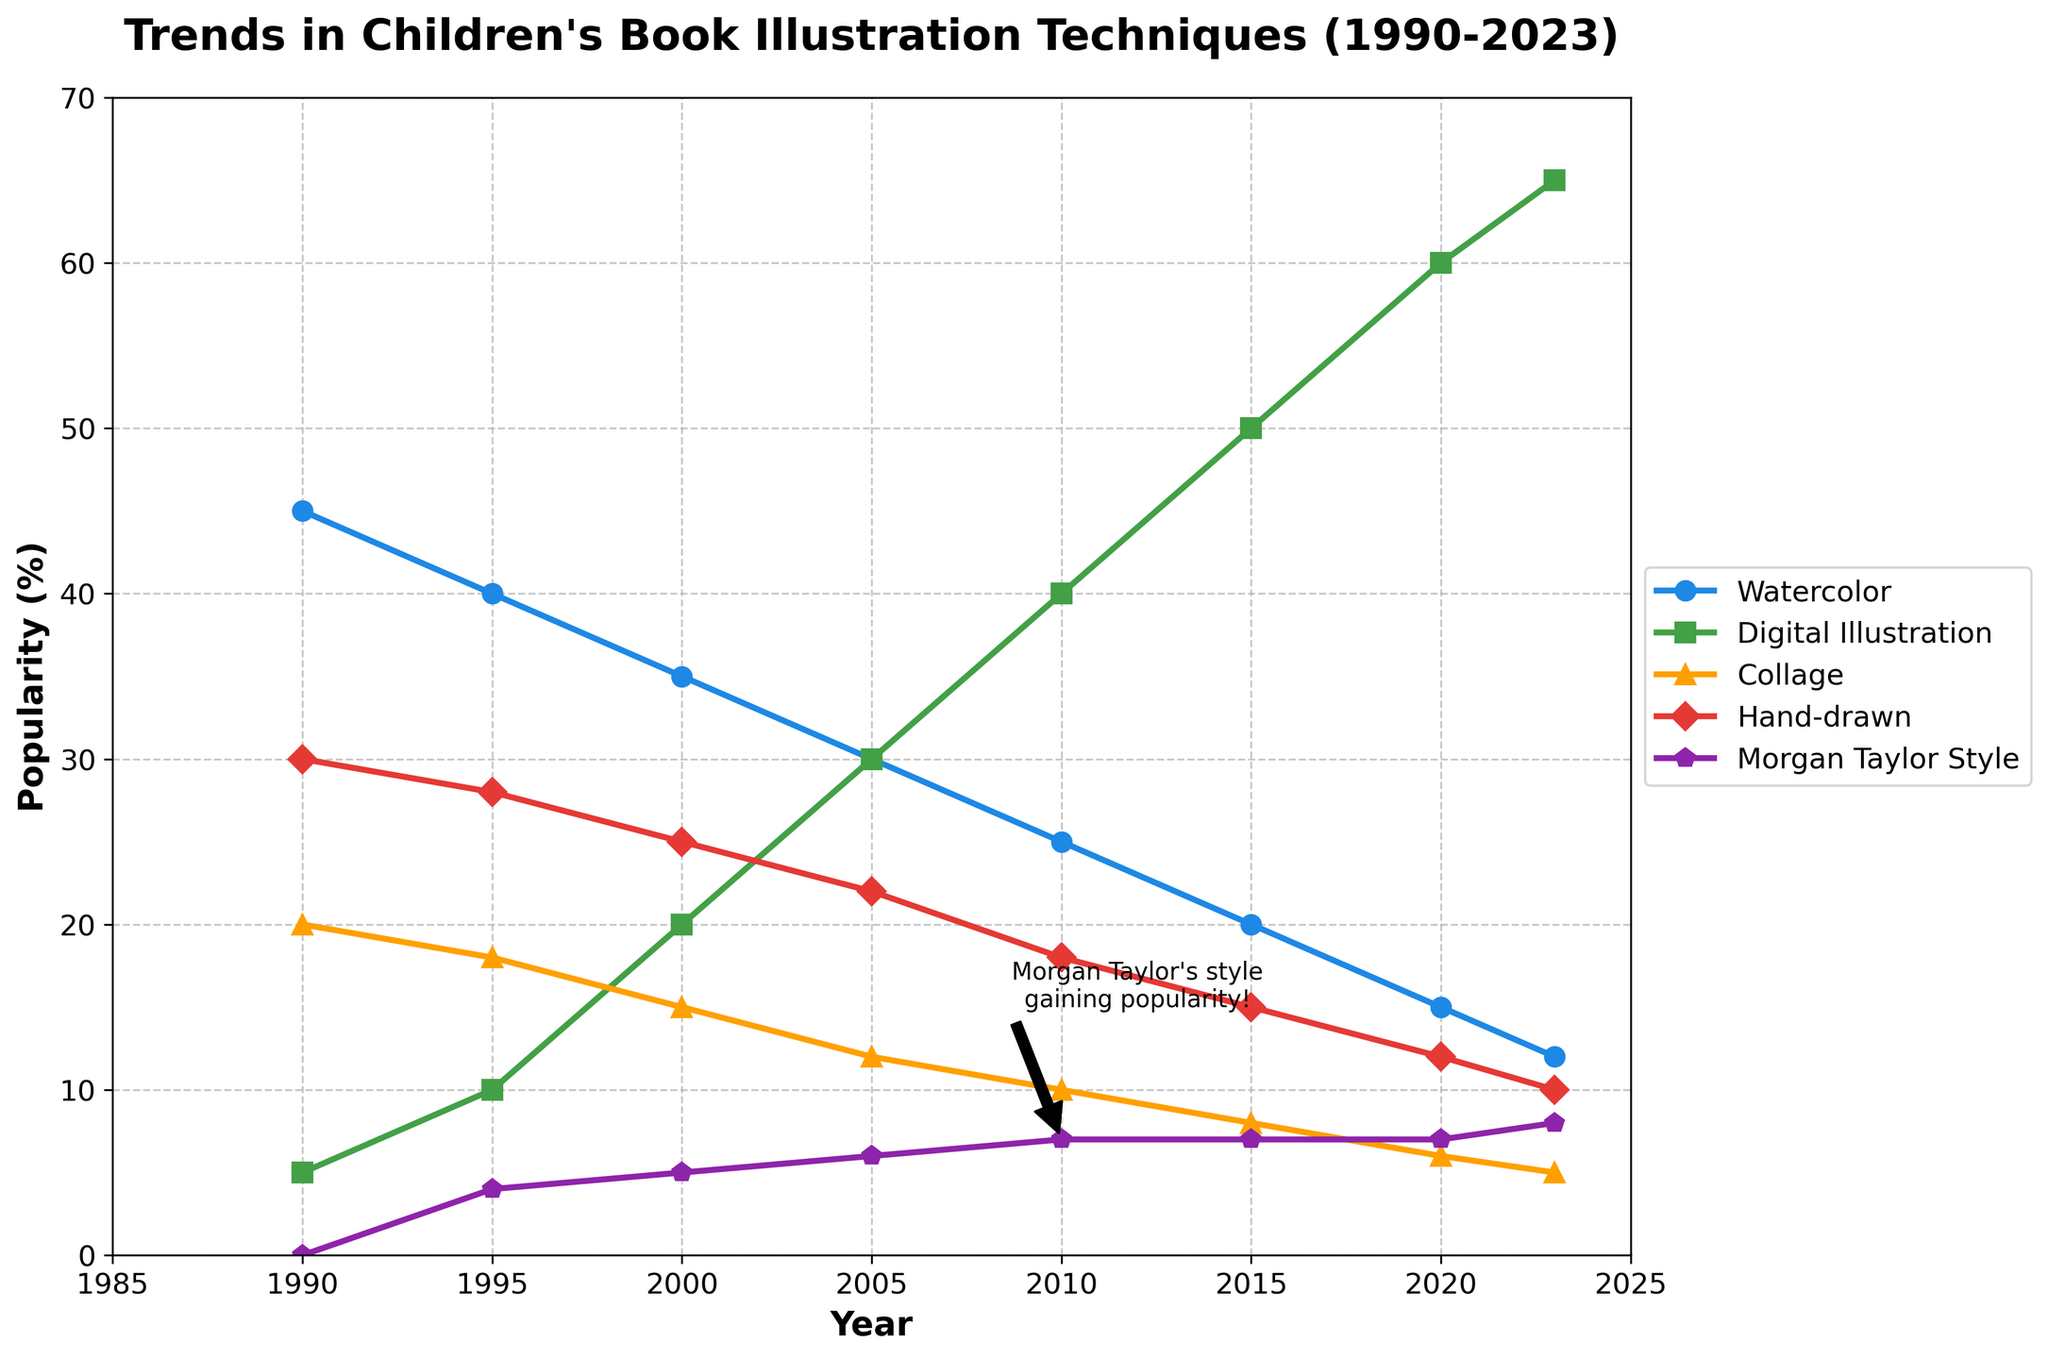Which illustration technique shows a consistent increase in popularity from 1990 to 2023? By observing the trend lines on the chart, Digital Illustration is the only technique that shows a consistent increase in popularity from 1990 (5%) to 2023 (65%).
Answer: Digital Illustration How did Morgan Taylor's style trend from 1990 to 2023? By examining the plot, Morgan Taylor's style started gaining popularity in 1995 and steadily increased from 4% in 1995 to 8% in 2023.
Answer: Increasing Which two techniques had the highest popularity in 2023? From the data points on the chart, Digital Illustration had the highest popularity at 65%, followed by Watercolor at 12%.
Answer: Digital Illustration and Watercolor Compare the popularity of Hand-drawn and Collage techniques in 2000. For the year 2000, the plot shows that Hand-drawn had a 25% popularity rate, while Collage had a 15% popularity rate, making Hand-drawn more popular.
Answer: Hand-drawn What is the percentage difference between the popularity of Watercolor and Digital Illustration in 2015? In 2015, Watercolor's popularity was 20% and Digital Illustration's was 50%. The percentage difference is calculated as 50% - 20% = 30%.
Answer: 30% Identify the technique with the steepest decline in popularity from 1990 to 2023. By analyzing the overall decrease across the years, Watercolor declined from 45% in 1990 to 12% in 2023, showing the steepest decline among all techniques.
Answer: Watercolor What can be inferred about the popularity of Collage from 1990 to 2023? The chart shows that Collage's popularity smoothly decreased from 20% in 1990 to 5% in 2023, indicating a steady decline in use over time.
Answer: Declining In which year did Morgan Taylor's style reach a popularity level of 7%? According to the graph, in 2010, Morgan Taylor's style reached a popularity level of 7% and stayed there until 2020.
Answer: 2010 If we sum the popularity percentages of Hand-drawn and Morgan Taylor's style in 2023, what do we get? The popularity percentages for Hand-drawn and Morgan Taylor's style in 2023 are 10% and 8%, respectively. The sum is 10% + 8% = 18%.
Answer: 18% 